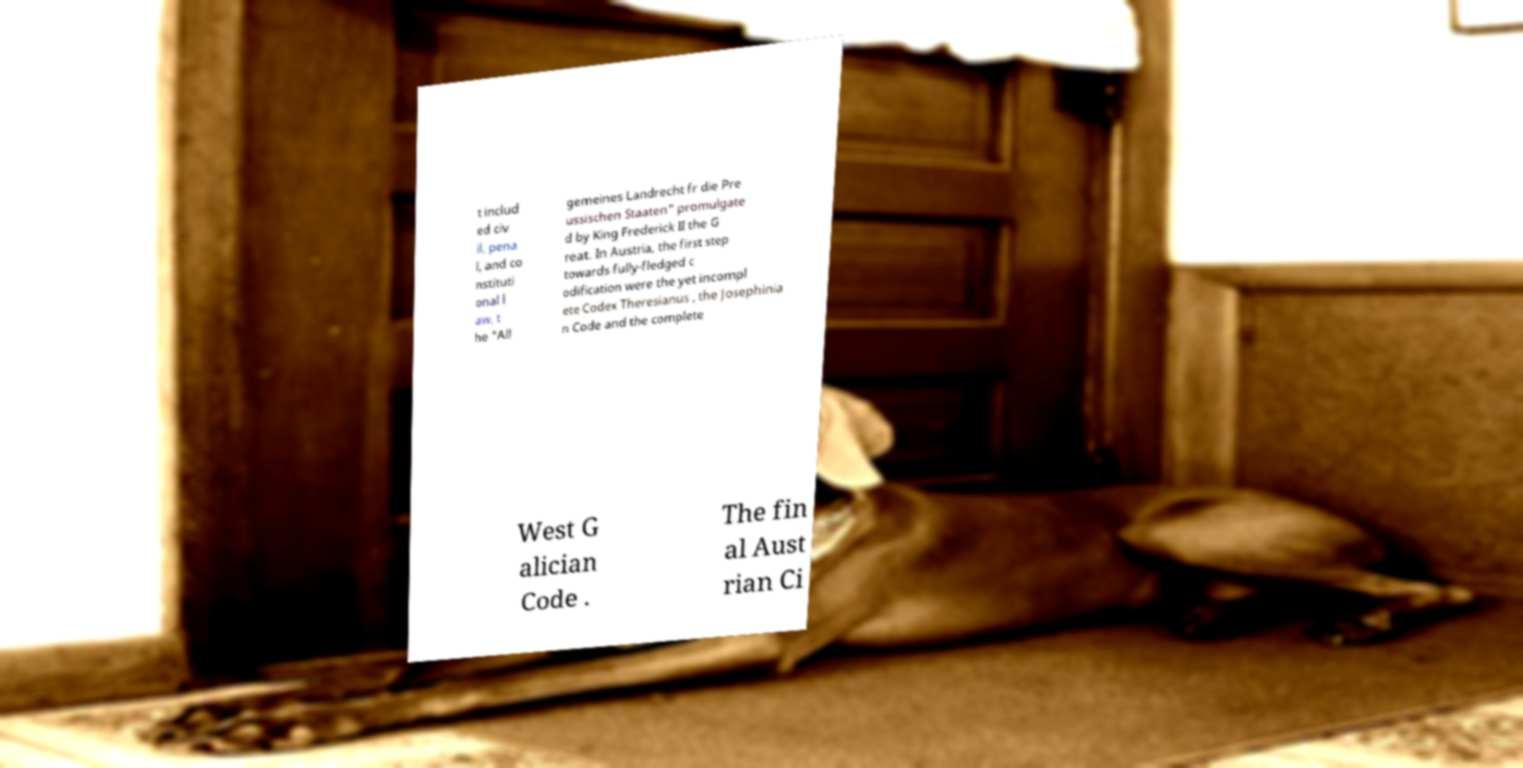What messages or text are displayed in this image? I need them in a readable, typed format. t includ ed civ il, pena l, and co nstituti onal l aw, t he "All gemeines Landrecht fr die Pre ussischen Staaten" promulgate d by King Frederick II the G reat. In Austria, the first step towards fully-fledged c odification were the yet incompl ete Codex Theresianus , the Josephinia n Code and the complete West G alician Code . The fin al Aust rian Ci 